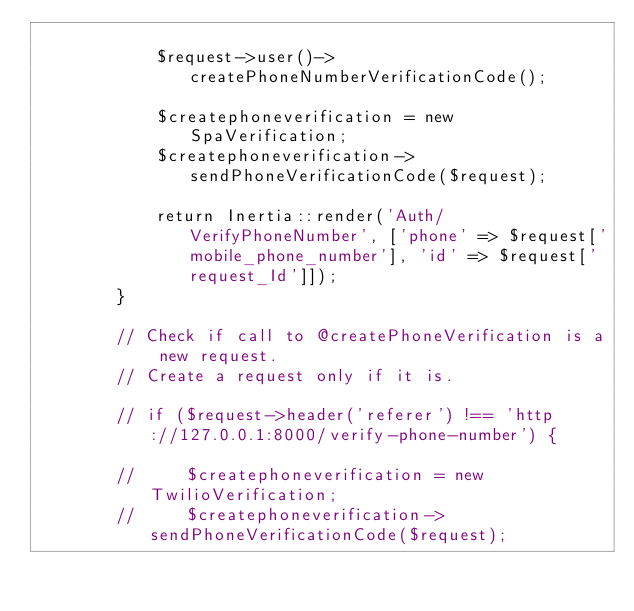Convert code to text. <code><loc_0><loc_0><loc_500><loc_500><_PHP_>
            $request->user()->createPhoneNumberVerificationCode();

            $createphoneverification = new SpaVerification;
            $createphoneverification->sendPhoneVerificationCode($request);
             
            return Inertia::render('Auth/VerifyPhoneNumber', ['phone' => $request['mobile_phone_number'], 'id' => $request['request_Id']]);    
        }

        // Check if call to @createPhoneVerification is a new request.
        // Create a request only if it is. 

        // if ($request->header('referer') !== 'http://127.0.0.1:8000/verify-phone-number') {
        
        //     $createphoneverification = new TwilioVerification;
        //     $createphoneverification->sendPhoneVerificationCode($request);
            </code> 